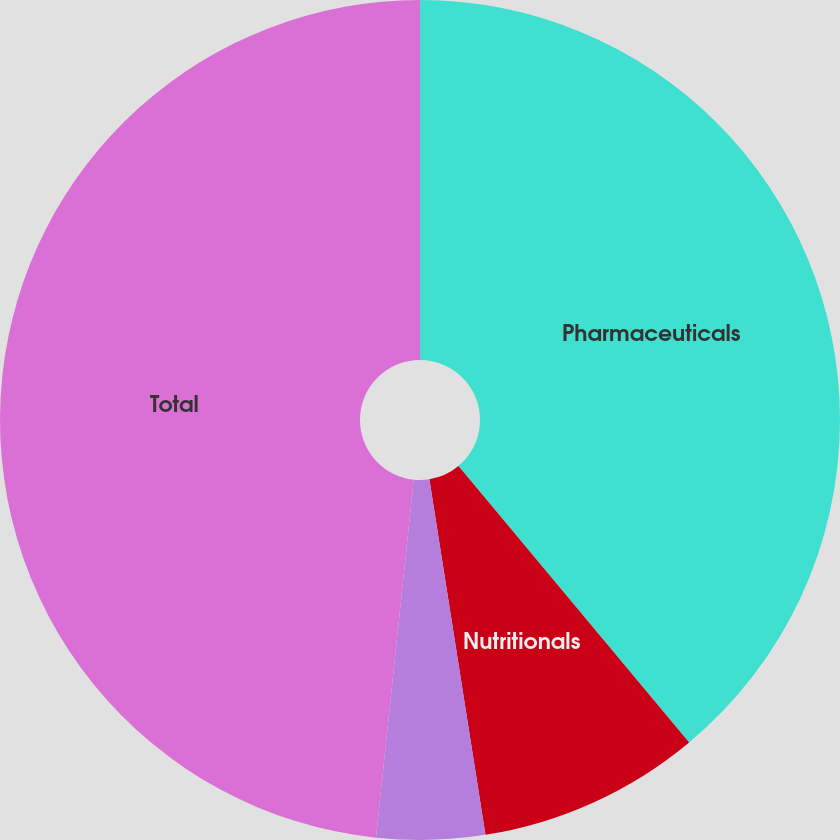Convert chart. <chart><loc_0><loc_0><loc_500><loc_500><pie_chart><fcel>Pharmaceuticals<fcel>Nutritionals<fcel>Other Health Care<fcel>Total<nl><fcel>38.93%<fcel>8.58%<fcel>4.16%<fcel>48.33%<nl></chart> 